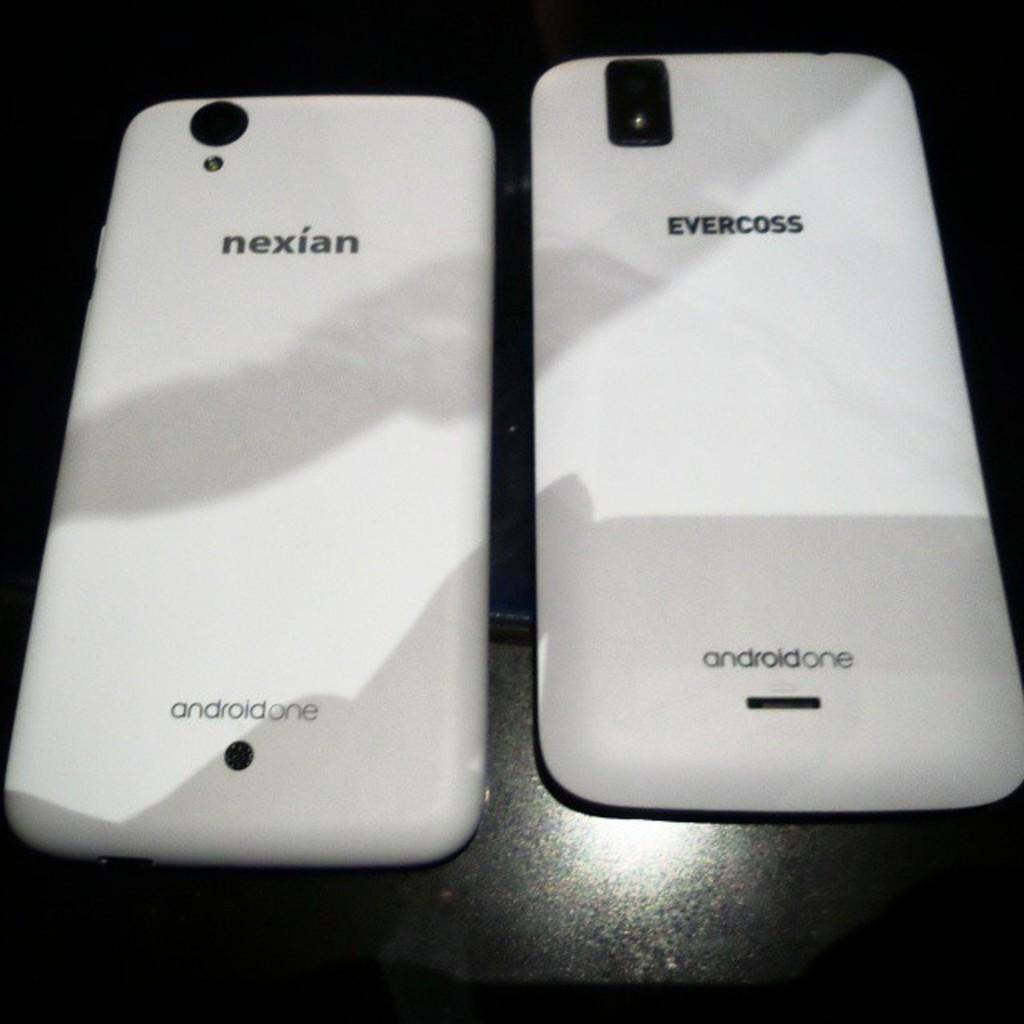Provide a one-sentence caption for the provided image. Two cell phones are next to each other and they are both Android. 